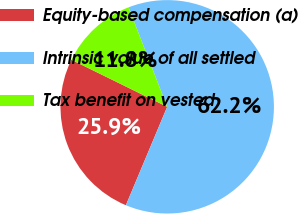<chart> <loc_0><loc_0><loc_500><loc_500><pie_chart><fcel>Equity-based compensation (a)<fcel>Intrinsic value of all settled<fcel>Tax benefit on vested<nl><fcel>25.94%<fcel>62.22%<fcel>11.84%<nl></chart> 